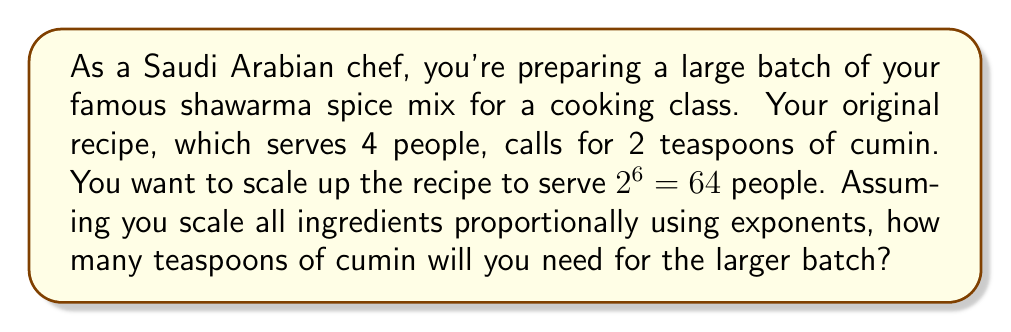Solve this math problem. Let's approach this step-by-step:

1) First, we need to determine the scaling factor. We're going from 4 people to 64 people.
   
   Scaling factor = $\frac{64}{4} = 16$

2) We can express this scaling factor as a power of 2:
   
   $16 = 2^4$

3) Now, we need to scale the amount of cumin. The original recipe uses 2 teaspoons for 4 people.

4) When scaling ingredients using exponents, we use the following formula:
   
   New amount = Original amount $\times$ (Scaling factor)

5) In this case:
   
   New amount = $2 \times (2^4)$ teaspoons

6) Let's calculate this:
   
   $2 \times (2^4) = 2 \times 16 = 32$ teaspoons

Therefore, you'll need 32 teaspoons of cumin for the larger batch.
Answer: $32$ teaspoons of cumin 